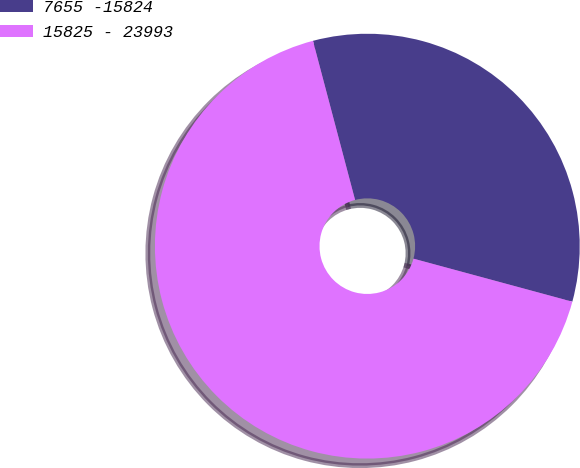Convert chart. <chart><loc_0><loc_0><loc_500><loc_500><pie_chart><fcel>7655 -15824<fcel>15825 - 23993<nl><fcel>33.33%<fcel>66.67%<nl></chart> 